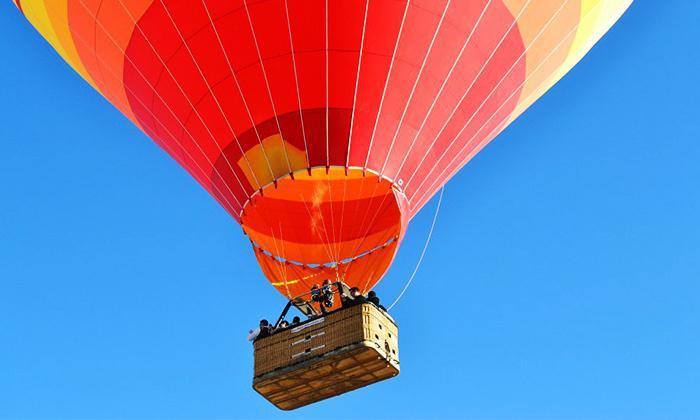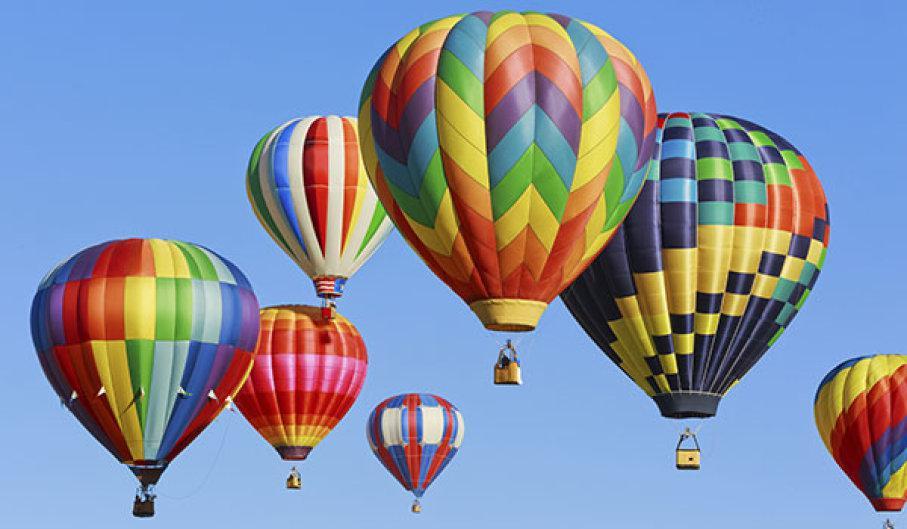The first image is the image on the left, the second image is the image on the right. For the images shown, is this caption "There is a rope that runs from the right side of the basket up to the balloon in the image on the left." true? Answer yes or no. Yes. The first image is the image on the left, the second image is the image on the right. Given the left and right images, does the statement "Right image features exactly one balloon, which is decorated with checkerboard pattern." hold true? Answer yes or no. No. 